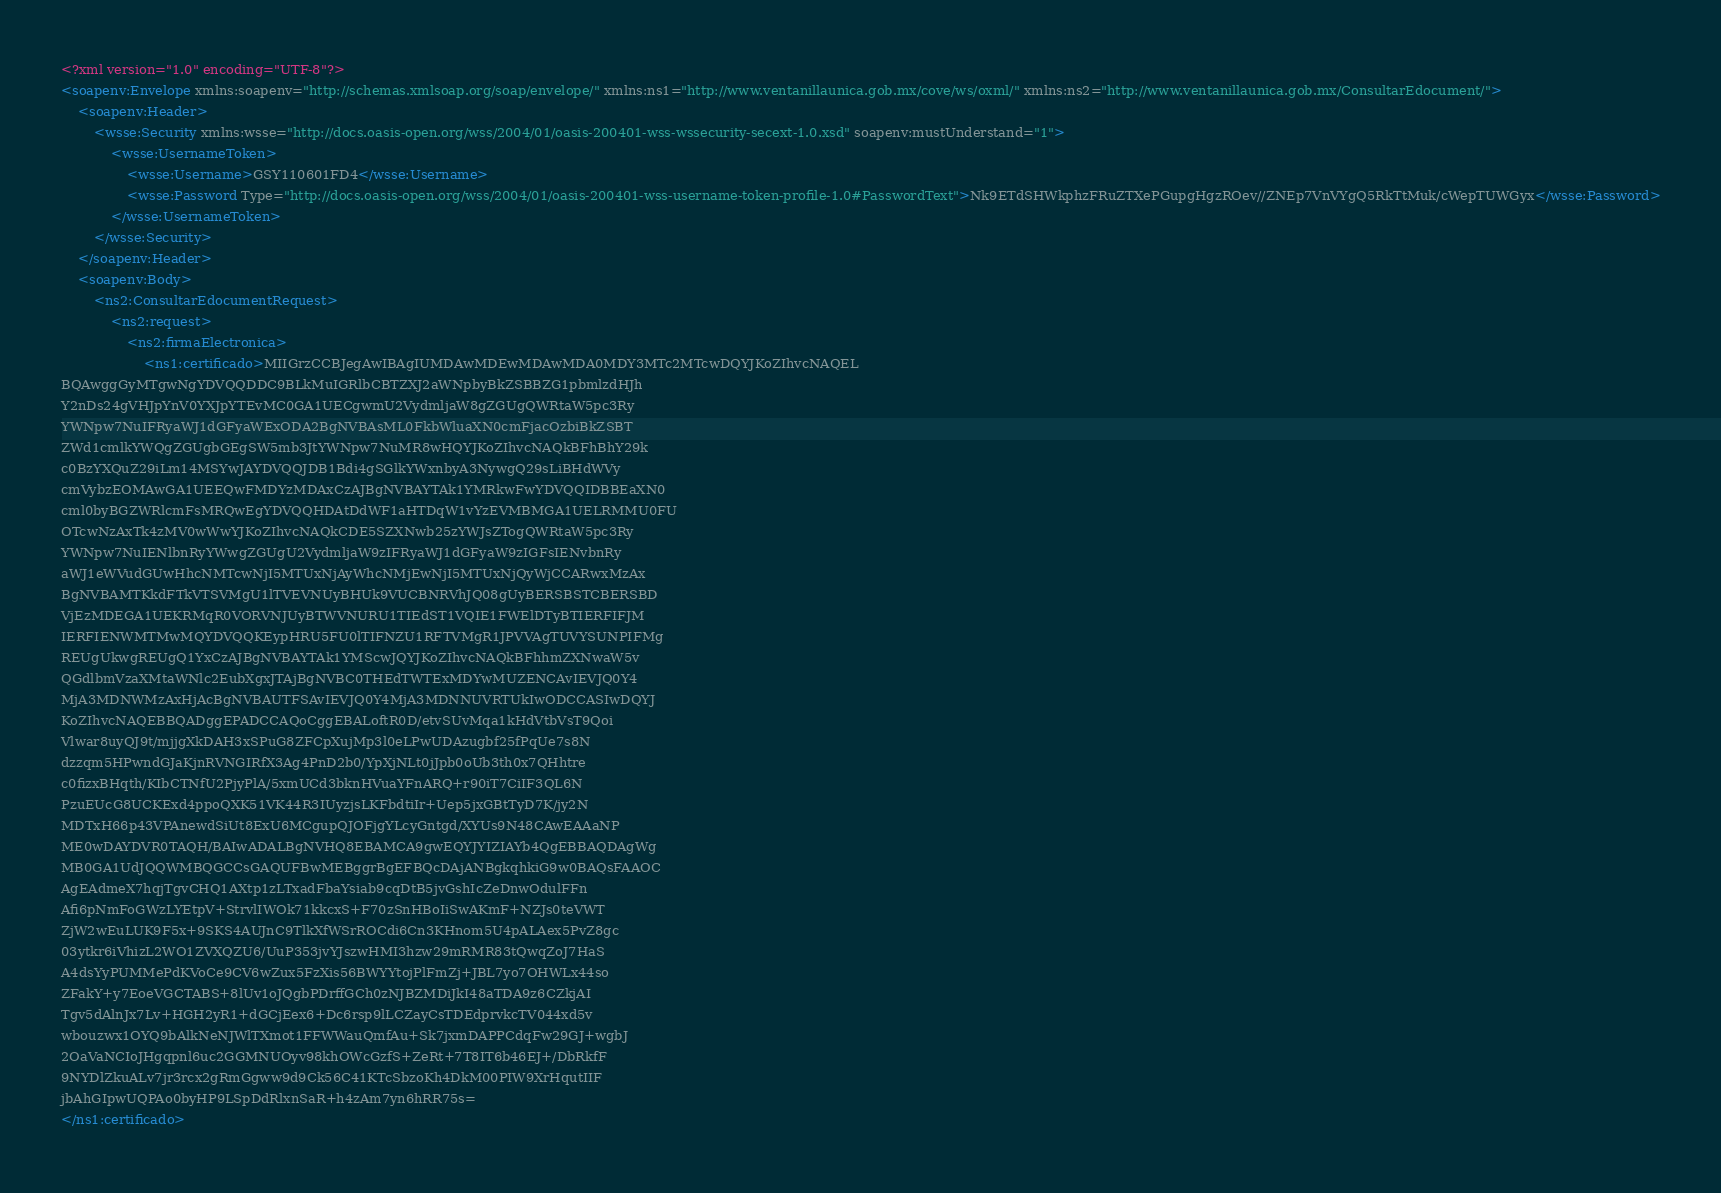Convert code to text. <code><loc_0><loc_0><loc_500><loc_500><_XML_><?xml version="1.0" encoding="UTF-8"?>
<soapenv:Envelope xmlns:soapenv="http://schemas.xmlsoap.org/soap/envelope/" xmlns:ns1="http://www.ventanillaunica.gob.mx/cove/ws/oxml/" xmlns:ns2="http://www.ventanillaunica.gob.mx/ConsultarEdocument/">
	<soapenv:Header>
		<wsse:Security xmlns:wsse="http://docs.oasis-open.org/wss/2004/01/oasis-200401-wss-wssecurity-secext-1.0.xsd" soapenv:mustUnderstand="1">
			<wsse:UsernameToken> 
				<wsse:Username>GSY110601FD4</wsse:Username> 
				<wsse:Password Type="http://docs.oasis-open.org/wss/2004/01/oasis-200401-wss-username-token-profile-1.0#PasswordText">Nk9ETdSHWkphzFRuZTXePGupgHgzROev//ZNEp7VnVYgQ5RkTtMuk/cWepTUWGyx</wsse:Password>
			</wsse:UsernameToken> 
		</wsse:Security>
	</soapenv:Header>
	<soapenv:Body> 
		<ns2:ConsultarEdocumentRequest>
	    	<ns2:request>
			    <ns2:firmaElectronica> 
					<ns1:certificado>MIIGrzCCBJegAwIBAgIUMDAwMDEwMDAwMDA0MDY3MTc2MTcwDQYJKoZIhvcNAQEL
BQAwggGyMTgwNgYDVQQDDC9BLkMuIGRlbCBTZXJ2aWNpbyBkZSBBZG1pbmlzdHJh
Y2nDs24gVHJpYnV0YXJpYTEvMC0GA1UECgwmU2VydmljaW8gZGUgQWRtaW5pc3Ry
YWNpw7NuIFRyaWJ1dGFyaWExODA2BgNVBAsML0FkbWluaXN0cmFjacOzbiBkZSBT
ZWd1cmlkYWQgZGUgbGEgSW5mb3JtYWNpw7NuMR8wHQYJKoZIhvcNAQkBFhBhY29k
c0BzYXQuZ29iLm14MSYwJAYDVQQJDB1Bdi4gSGlkYWxnbyA3NywgQ29sLiBHdWVy
cmVybzEOMAwGA1UEEQwFMDYzMDAxCzAJBgNVBAYTAk1YMRkwFwYDVQQIDBBEaXN0
cml0byBGZWRlcmFsMRQwEgYDVQQHDAtDdWF1aHTDqW1vYzEVMBMGA1UELRMMU0FU
OTcwNzAxTk4zMV0wWwYJKoZIhvcNAQkCDE5SZXNwb25zYWJsZTogQWRtaW5pc3Ry
YWNpw7NuIENlbnRyYWwgZGUgU2VydmljaW9zIFRyaWJ1dGFyaW9zIGFsIENvbnRy
aWJ1eWVudGUwHhcNMTcwNjI5MTUxNjAyWhcNMjEwNjI5MTUxNjQyWjCCARwxMzAx
BgNVBAMTKkdFTkVTSVMgU1lTVEVNUyBHUk9VUCBNRVhJQ08gUyBERSBSTCBERSBD
VjEzMDEGA1UEKRMqR0VORVNJUyBTWVNURU1TIEdST1VQIE1FWElDTyBTIERFIFJM
IERFIENWMTMwMQYDVQQKEypHRU5FU0lTIFNZU1RFTVMgR1JPVVAgTUVYSUNPIFMg
REUgUkwgREUgQ1YxCzAJBgNVBAYTAk1YMScwJQYJKoZIhvcNAQkBFhhmZXNwaW5v
QGdlbmVzaXMtaWNlc2EubXgxJTAjBgNVBC0THEdTWTExMDYwMUZENCAvIEVJQ0Y4
MjA3MDNWMzAxHjAcBgNVBAUTFSAvIEVJQ0Y4MjA3MDNNUVRTUkIwODCCASIwDQYJ
KoZIhvcNAQEBBQADggEPADCCAQoCggEBALoftR0D/etvSUvMqa1kHdVtbVsT9Qoi
Vlwar8uyQJ9t/mjjgXkDAH3xSPuG8ZFCpXujMp3l0eLPwUDAzugbf25fPqUe7s8N
dzzqm5HPwndGJaKjnRVNGIRfX3Ag4PnD2b0/YpXjNLt0jJpb0oUb3th0x7QHhtre
c0fizxBHqth/KIbCTNfU2PjyPlA/5xmUCd3bknHVuaYFnARQ+r90iT7CiIF3QL6N
PzuEUcG8UCKExd4ppoQXK51VK44R3IUyzjsLKFbdtiIr+Uep5jxGBtTyD7K/jy2N
MDTxH66p43VPAnewdSiUt8ExU6MCgupQJOFjgYLcyGntgd/XYUs9N48CAwEAAaNP
ME0wDAYDVR0TAQH/BAIwADALBgNVHQ8EBAMCA9gwEQYJYIZIAYb4QgEBBAQDAgWg
MB0GA1UdJQQWMBQGCCsGAQUFBwMEBggrBgEFBQcDAjANBgkqhkiG9w0BAQsFAAOC
AgEAdmeX7hqjTgvCHQ1AXtp1zLTxadFbaYsiab9cqDtB5jvGshIcZeDnwOdulFFn
Afi6pNmFoGWzLYEtpV+StrvlIWOk71kkcxS+F70zSnHBoIiSwAKmF+NZJs0teVWT
ZjW2wEuLUK9F5x+9SKS4AUJnC9TlkXfWSrROCdi6Cn3KHnom5U4pALAex5PvZ8gc
03ytkr6iVhizL2WO1ZVXQZU6/UuP353jvYJszwHMI3hzw29mRMR83tQwqZoJ7HaS
A4dsYyPUMMePdKVoCe9CV6wZux5FzXis56BWYYtojPlFmZj+JBL7yo7OHWLx44so
ZFakY+y7EoeVGCTABS+8lUv1oJQgbPDrffGCh0zNJBZMDiJkI48aTDA9z6CZkjAI
Tgv5dAlnJx7Lv+HGH2yR1+dGCjEex6+Dc6rsp9lLCZayCsTDEdprvkcTV044xd5v
wbouzwx1OYQ9bAlkNeNJWlTXmot1FFWWauQmfAu+Sk7jxmDAPPCdqFw29GJ+wgbJ
2OaVaNCIoJHgqpnl6uc2GGMNUOyv98khOWcGzfS+ZeRt+7T8IT6b46EJ+/DbRkfF
9NYDlZkuALv7jr3rcx2gRmGgww9d9Ck56C41KTcSbzoKh4DkM00PIW9XrHqutIIF
jbAhGIpwUQPAo0byHP9LSpDdRlxnSaR+h4zAm7yn6hRR75s=
</ns1:certificado></code> 